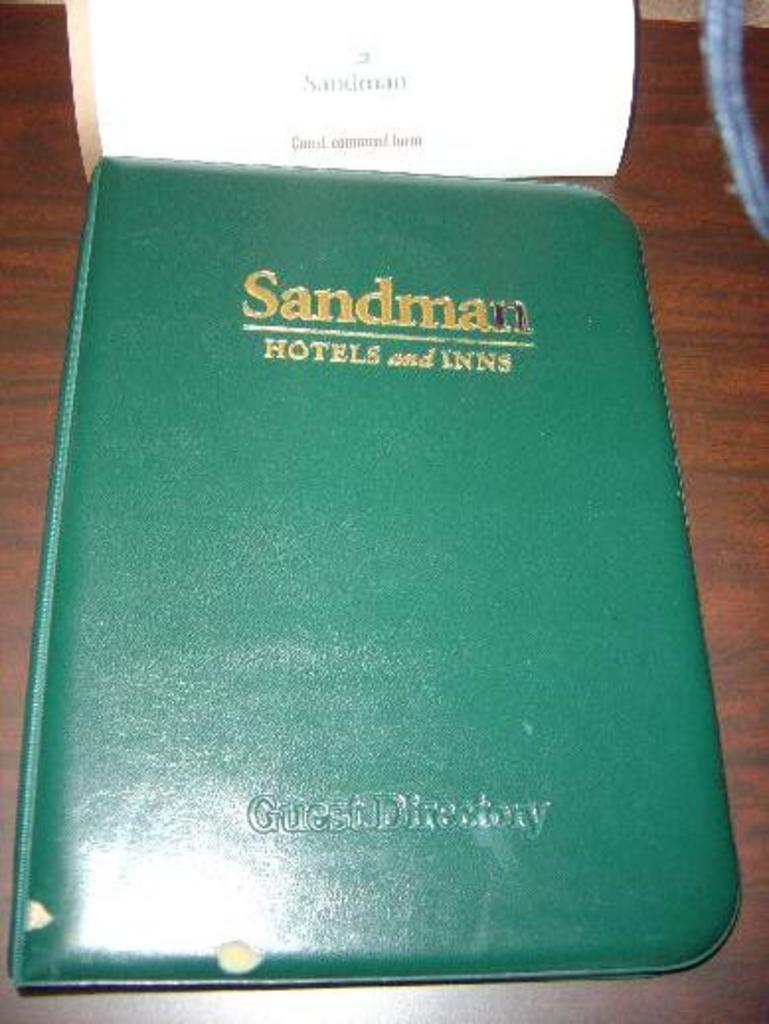<image>
Render a clear and concise summary of the photo. A leather binder from the Sandman hotel holds the guest directory. 